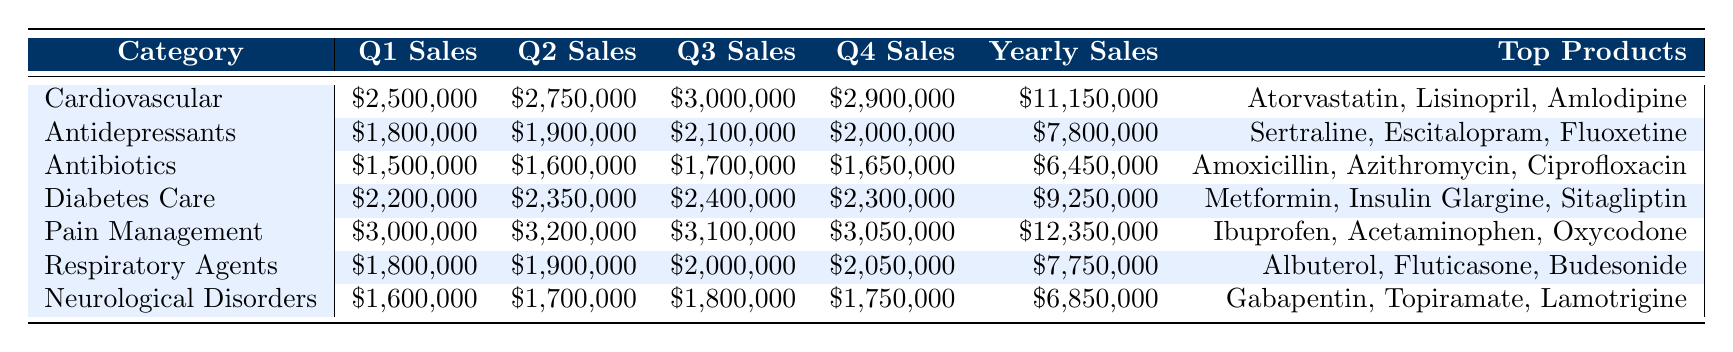What was the highest sales category in Q2? The sales values for Q2 in each category are: Cardiovascular ($2,750,000), Antidepressants ($1,900,000), Antibiotics ($1,600,000), Diabetes Care ($2,350,000), Pain Management ($3,200,000), Respiratory Agents ($1,900,000), Neurological Disorders ($1,700,000). Pain Management has the highest value at $3,200,000.
Answer: Pain Management Which category had the lowest total yearly sales? The total yearly sales for each category are: Cardiovascular ($11,150,000), Antidepressants ($7,800,000), Antibiotics ($6,450,000), Diabetes Care ($9,250,000), Pain Management ($12,350,000), Respiratory Agents ($7,750,000), Neurological Disorders ($6,850,000). Antibiotics has the lowest total yearly sales at $6,450,000.
Answer: Antibiotics What was the increase in sales from Q1 to Q3 for Diabetes Care? The sales for Diabetes Care are: Q1: $2,200,000, Q3: $2,400,000. The increase can be calculated as $2,400,000 - $2,200,000 = $200,000.
Answer: $200,000 Which category had the highest sales in Q4? The sales for Q4 in each category are: Cardiovascular ($2,900,000), Antidepressants ($2,000,000), Antibiotics ($1,650,000), Diabetes Care ($2,300,000), Pain Management ($3,050,000), Respiratory Agents ($2,050,000), Neurological Disorders ($1,750,000). Pain Management recorded the highest sales in Q4 at $3,050,000.
Answer: Pain Management What is the total sales for Antibiotics in the year, and how does it compare with Respiratory Agents? The yearly sales for Antibiotics is $6,450,000 and for Respiratory Agents is $7,750,000. To compare, $6,450,000 is less than $7,750,000, meaning Antibiotics had lower sales than Respiratory Agents.
Answer: Antibiotics had lower sales than Respiratory Agents What was the average sales for Pain Management over the four quarters? The sales for Pain Management are: Q1: $3,000,000, Q2: $3,200,000, Q3: $3,100,000, Q4: $3,050,000. To find the average: (3,000,000 + 3,200,000 + 3,100,000 + 3,050,000) / 4 = $3,087,500.
Answer: $3,087,500 Did any category show a decrease in sales from Q3 to Q4? The sales for Q3 and Q4 are: Cardiovascular (Q3: $3,000,000, Q4: $2,900,000), Antidepressants (Q3: $2,100,000, Q4: $2,000,000), Antibiotics (Q3: $1,700,000, Q4: $1,650,000), Diabetes Care (Q3: $2,400,000, Q4: $2,300,000), Pain Management (Q3: $3,100,000, Q4: $3,050,000), Respiratory Agents (Q3: $2,000,000, Q4: $2,050,000), Neurological Disorders (Q3: $1,800,000, Q4: $1,750,000). All categories except Respiratory Agents showed a decrease; it showed an increase. Therefore, the answer is Yes.
Answer: Yes What is the total sales for the top three categories and how do they compare with the total sales for Neurological Disorders? The top three categories are Pain Management ($12,350,000), Cardiovascular ($11,150,000), and Diabetes Care ($9,250,000). Total for top three: $12,350,000 + $11,150,000 + $9,250,000 = $32,750,000. Neurological Disorders sales are $6,850,000. $32,750,000 is significantly higher than $6,850,000.
Answer: The total for the top three is higher than Neurological Disorders 